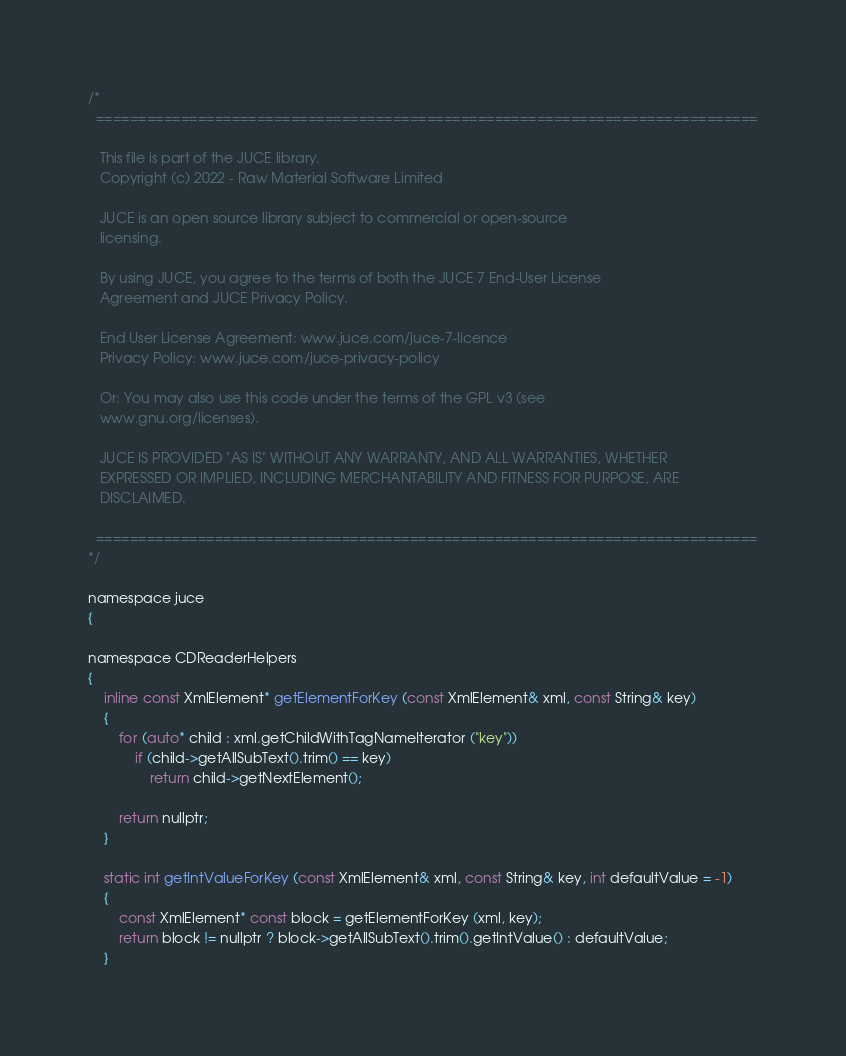<code> <loc_0><loc_0><loc_500><loc_500><_ObjectiveC_>/*
  ==============================================================================

   This file is part of the JUCE library.
   Copyright (c) 2022 - Raw Material Software Limited

   JUCE is an open source library subject to commercial or open-source
   licensing.

   By using JUCE, you agree to the terms of both the JUCE 7 End-User License
   Agreement and JUCE Privacy Policy.

   End User License Agreement: www.juce.com/juce-7-licence
   Privacy Policy: www.juce.com/juce-privacy-policy

   Or: You may also use this code under the terms of the GPL v3 (see
   www.gnu.org/licenses).

   JUCE IS PROVIDED "AS IS" WITHOUT ANY WARRANTY, AND ALL WARRANTIES, WHETHER
   EXPRESSED OR IMPLIED, INCLUDING MERCHANTABILITY AND FITNESS FOR PURPOSE, ARE
   DISCLAIMED.

  ==============================================================================
*/

namespace juce
{

namespace CDReaderHelpers
{
    inline const XmlElement* getElementForKey (const XmlElement& xml, const String& key)
    {
        for (auto* child : xml.getChildWithTagNameIterator ("key"))
            if (child->getAllSubText().trim() == key)
                return child->getNextElement();

        return nullptr;
    }

    static int getIntValueForKey (const XmlElement& xml, const String& key, int defaultValue = -1)
    {
        const XmlElement* const block = getElementForKey (xml, key);
        return block != nullptr ? block->getAllSubText().trim().getIntValue() : defaultValue;
    }
</code> 